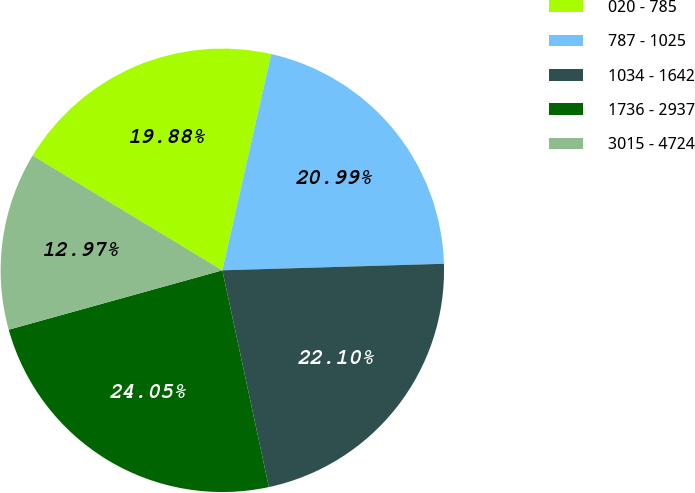Convert chart to OTSL. <chart><loc_0><loc_0><loc_500><loc_500><pie_chart><fcel>020 - 785<fcel>787 - 1025<fcel>1034 - 1642<fcel>1736 - 2937<fcel>3015 - 4724<nl><fcel>19.88%<fcel>20.99%<fcel>22.1%<fcel>24.05%<fcel>12.97%<nl></chart> 